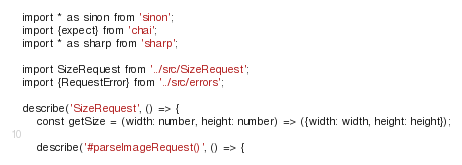<code> <loc_0><loc_0><loc_500><loc_500><_TypeScript_>import * as sinon from 'sinon';
import {expect} from 'chai';
import * as sharp from 'sharp';

import SizeRequest from '../src/SizeRequest';
import {RequestError} from '../src/errors';

describe('SizeRequest', () => {
    const getSize = (width: number, height: number) => ({width: width, height: height});

    describe('#parseImageRequest()', () => {</code> 